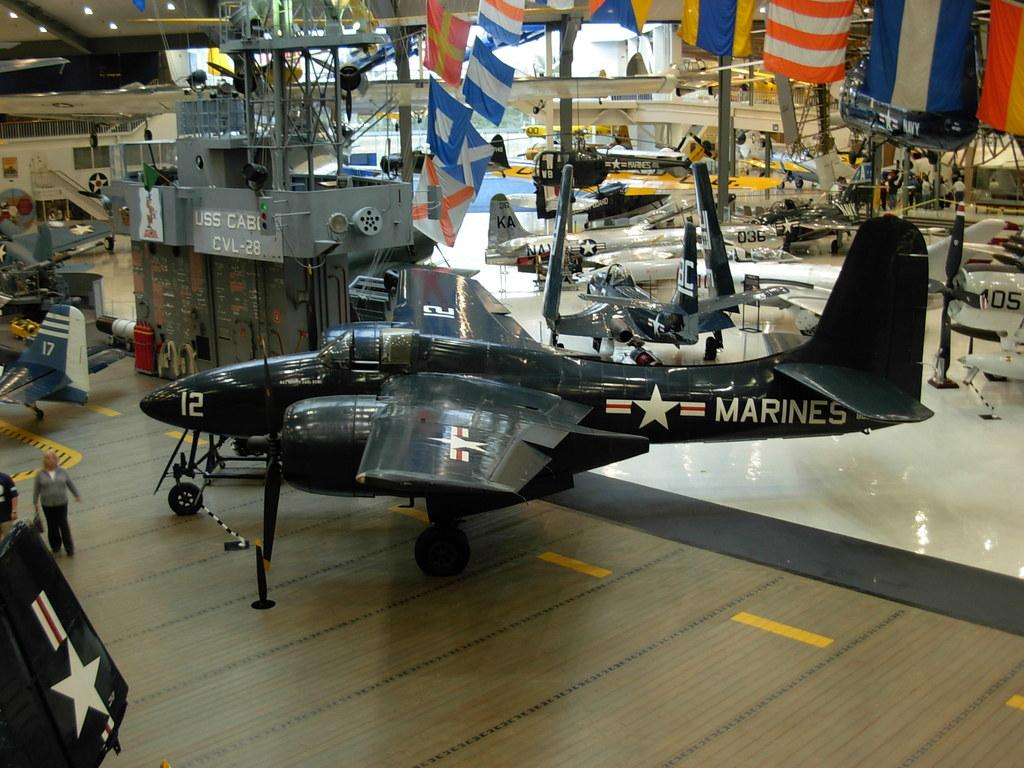Provide a one-sentence caption for the provided image. an airplane from the marines in a museum. 